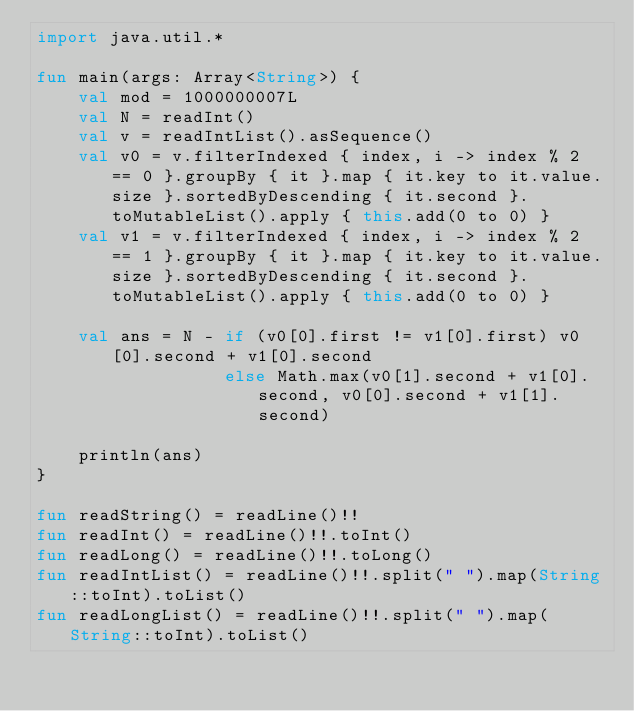Convert code to text. <code><loc_0><loc_0><loc_500><loc_500><_Kotlin_>import java.util.*

fun main(args: Array<String>) {
    val mod = 1000000007L
    val N = readInt()
    val v = readIntList().asSequence()
    val v0 = v.filterIndexed { index, i -> index % 2 == 0 }.groupBy { it }.map { it.key to it.value.size }.sortedByDescending { it.second }.toMutableList().apply { this.add(0 to 0) }
    val v1 = v.filterIndexed { index, i -> index % 2 == 1 }.groupBy { it }.map { it.key to it.value.size }.sortedByDescending { it.second }.toMutableList().apply { this.add(0 to 0) }

    val ans = N - if (v0[0].first != v1[0].first) v0[0].second + v1[0].second
                  else Math.max(v0[1].second + v1[0].second, v0[0].second + v1[1].second)

    println(ans)
}

fun readString() = readLine()!!
fun readInt() = readLine()!!.toInt()
fun readLong() = readLine()!!.toLong()
fun readIntList() = readLine()!!.split(" ").map(String::toInt).toList()
fun readLongList() = readLine()!!.split(" ").map(String::toInt).toList()
</code> 